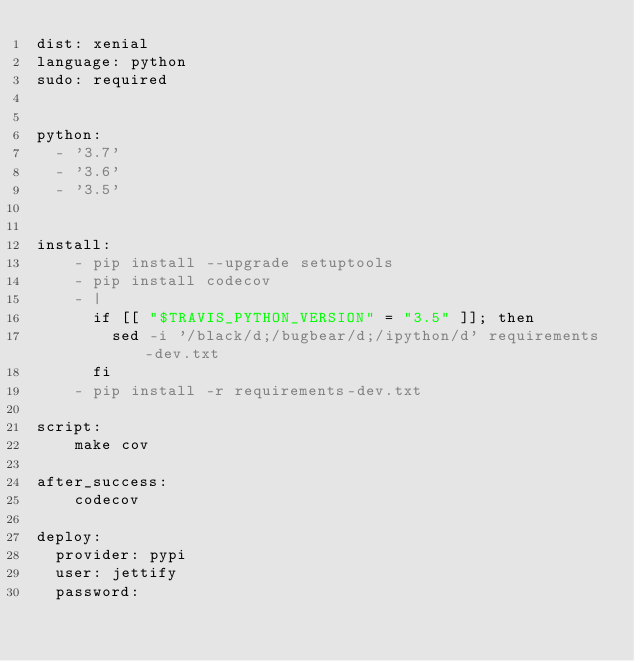<code> <loc_0><loc_0><loc_500><loc_500><_YAML_>dist: xenial
language: python
sudo: required


python:
  - '3.7'
  - '3.6'
  - '3.5'


install:
    - pip install --upgrade setuptools
    - pip install codecov
    - |
      if [[ "$TRAVIS_PYTHON_VERSION" = "3.5" ]]; then
        sed -i '/black/d;/bugbear/d;/ipython/d' requirements-dev.txt
      fi
    - pip install -r requirements-dev.txt

script:
    make cov

after_success:
    codecov

deploy:
  provider: pypi
  user: jettify
  password:</code> 